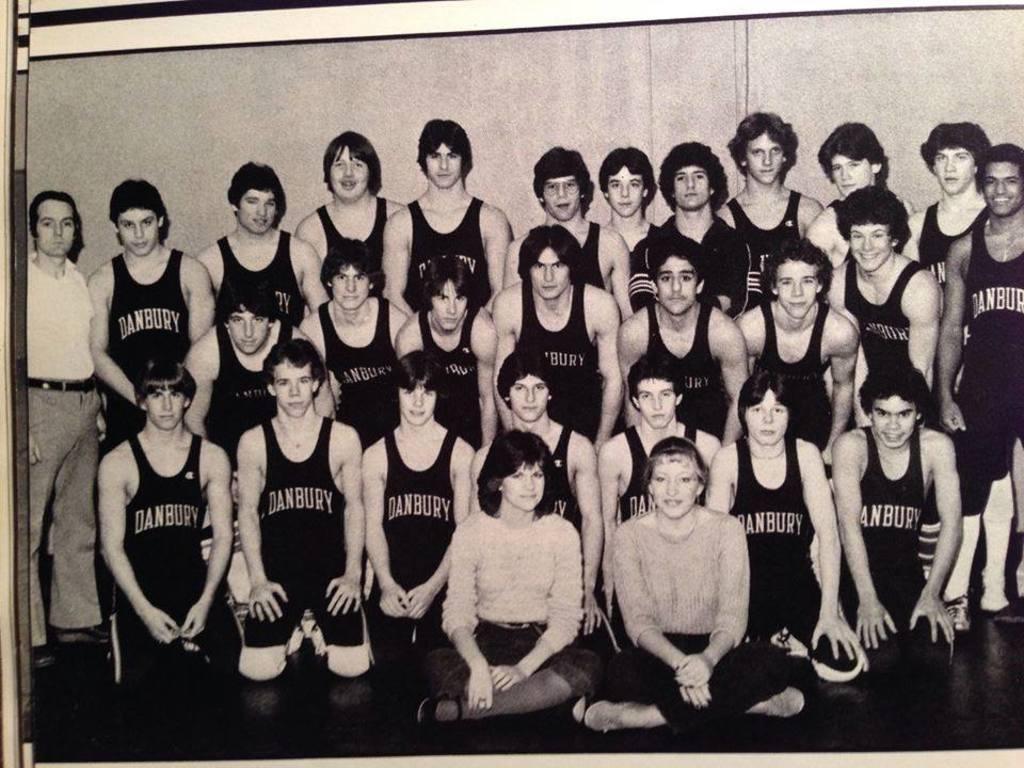What is the name of the team all the people are a part of?
Ensure brevity in your answer.  Danbury. 